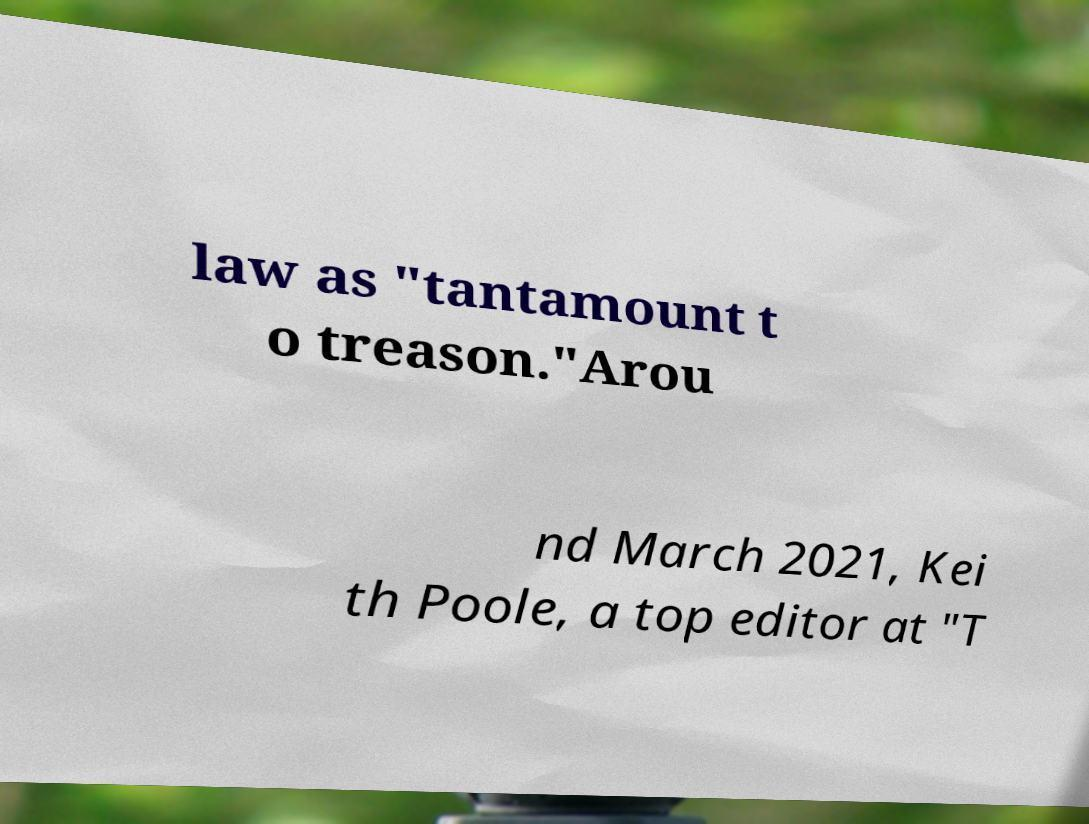Could you assist in decoding the text presented in this image and type it out clearly? law as "tantamount t o treason."Arou nd March 2021, Kei th Poole, a top editor at "T 